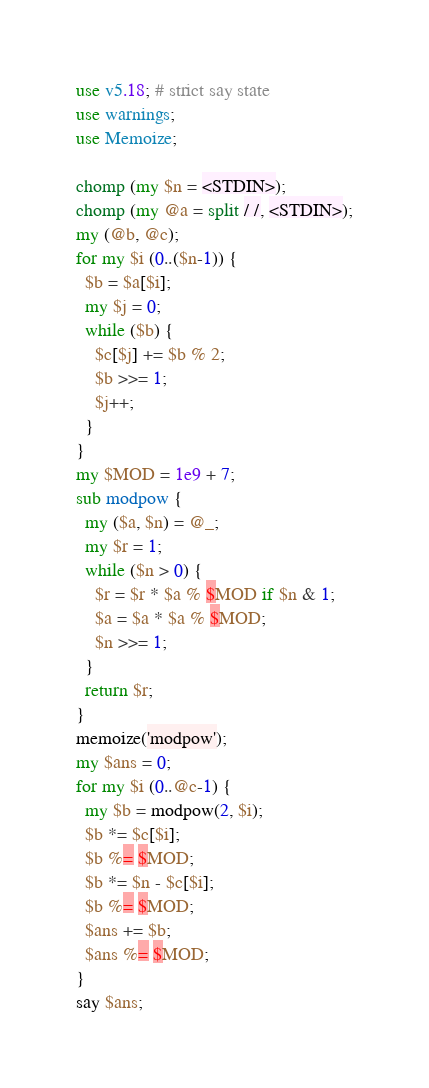<code> <loc_0><loc_0><loc_500><loc_500><_Perl_>use v5.18; # strict say state
use warnings;
use Memoize;

chomp (my $n = <STDIN>);
chomp (my @a = split / /, <STDIN>);
my (@b, @c);
for my $i (0..($n-1)) {
  $b = $a[$i];
  my $j = 0;
  while ($b) {
    $c[$j] += $b % 2;
    $b >>= 1;
    $j++;
  }
}
my $MOD = 1e9 + 7;
sub modpow {
  my ($a, $n) = @_;
  my $r = 1;
  while ($n > 0) {
    $r = $r * $a % $MOD if $n & 1;
    $a = $a * $a % $MOD;
    $n >>= 1;
  }
  return $r;
}
memoize('modpow');
my $ans = 0;
for my $i (0..@c-1) {
  my $b = modpow(2, $i);
  $b *= $c[$i];
  $b %= $MOD;
  $b *= $n - $c[$i];
  $b %= $MOD;
  $ans += $b;
  $ans %= $MOD;
}
say $ans;</code> 